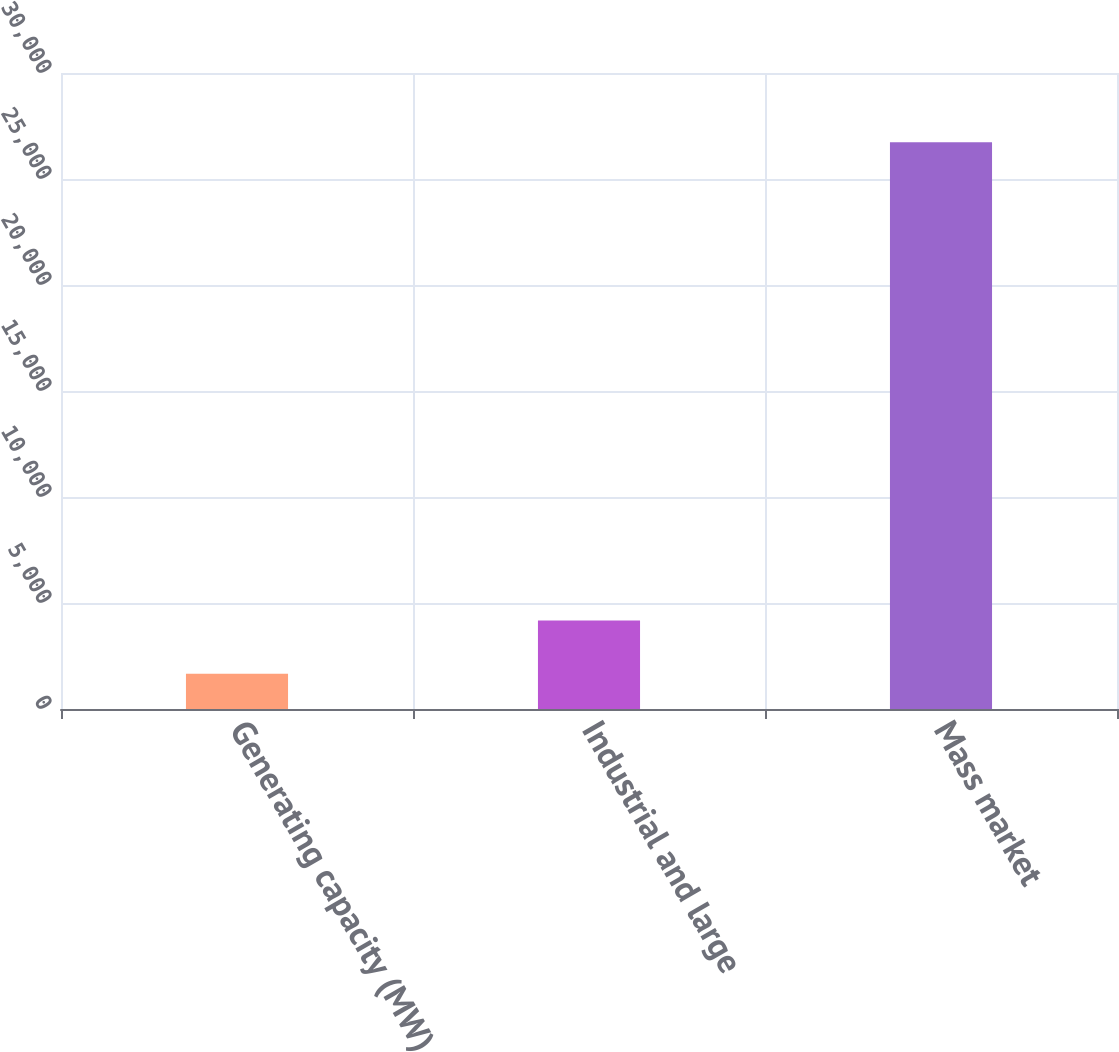<chart> <loc_0><loc_0><loc_500><loc_500><bar_chart><fcel>Generating capacity (MW)<fcel>Industrial and large<fcel>Mass market<nl><fcel>1668<fcel>4175<fcel>26738<nl></chart> 